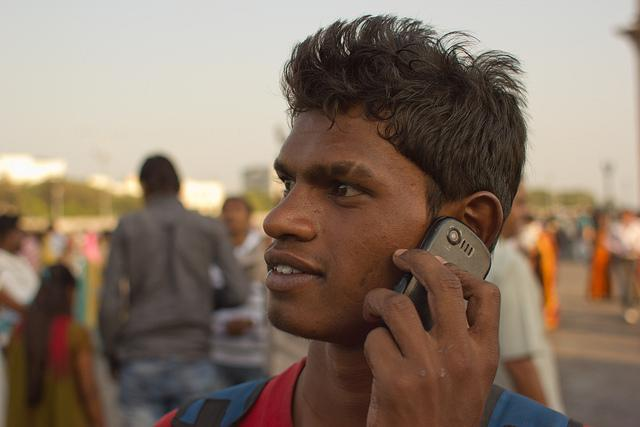What is a famous company that makes the device the man is holding?

Choices:
A) samsung
B) dell
C) hitachi
D) hoover samsung 